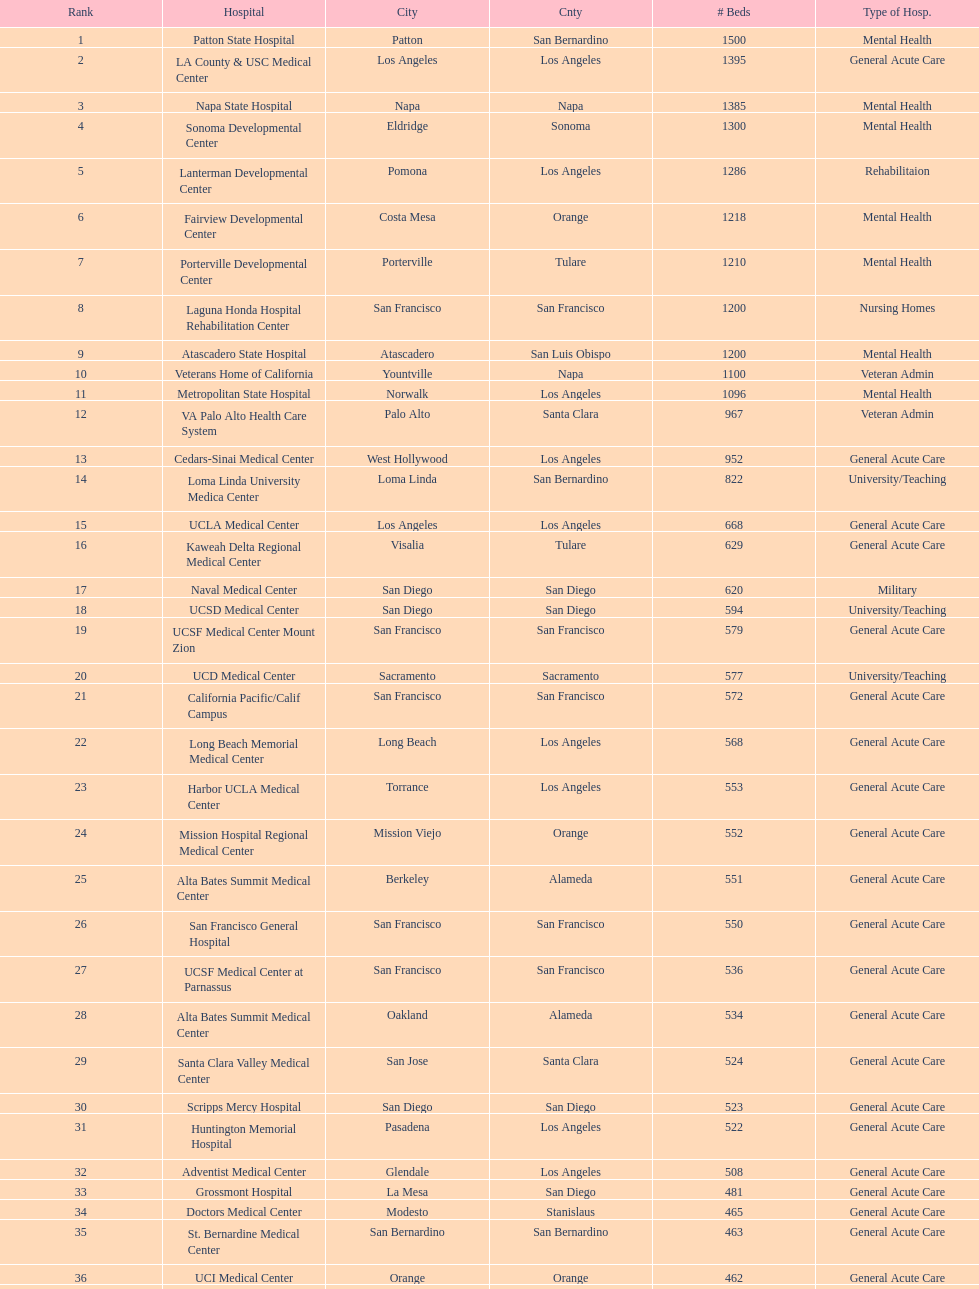What hospital in los angeles county providing hospital beds specifically for rehabilitation is ranked at least among the top 10 hospitals? Lanterman Developmental Center. 